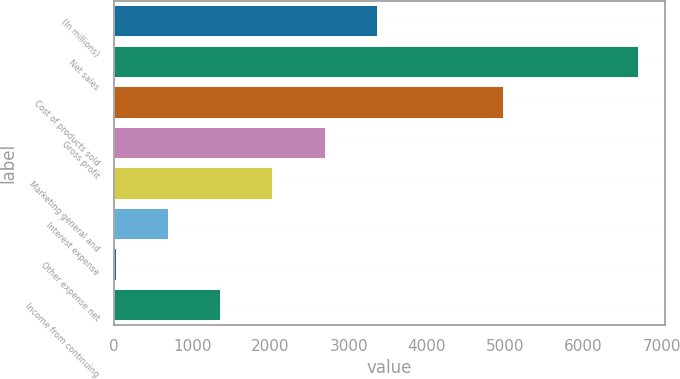<chart> <loc_0><loc_0><loc_500><loc_500><bar_chart><fcel>(In millions)<fcel>Net sales<fcel>Cost of products sold<fcel>Gross profit<fcel>Marketing general and<fcel>Interest expense<fcel>Other expense net<fcel>Income from continuing<nl><fcel>3373.3<fcel>6710.4<fcel>4983.4<fcel>2705.88<fcel>2038.46<fcel>703.62<fcel>36.2<fcel>1371.04<nl></chart> 